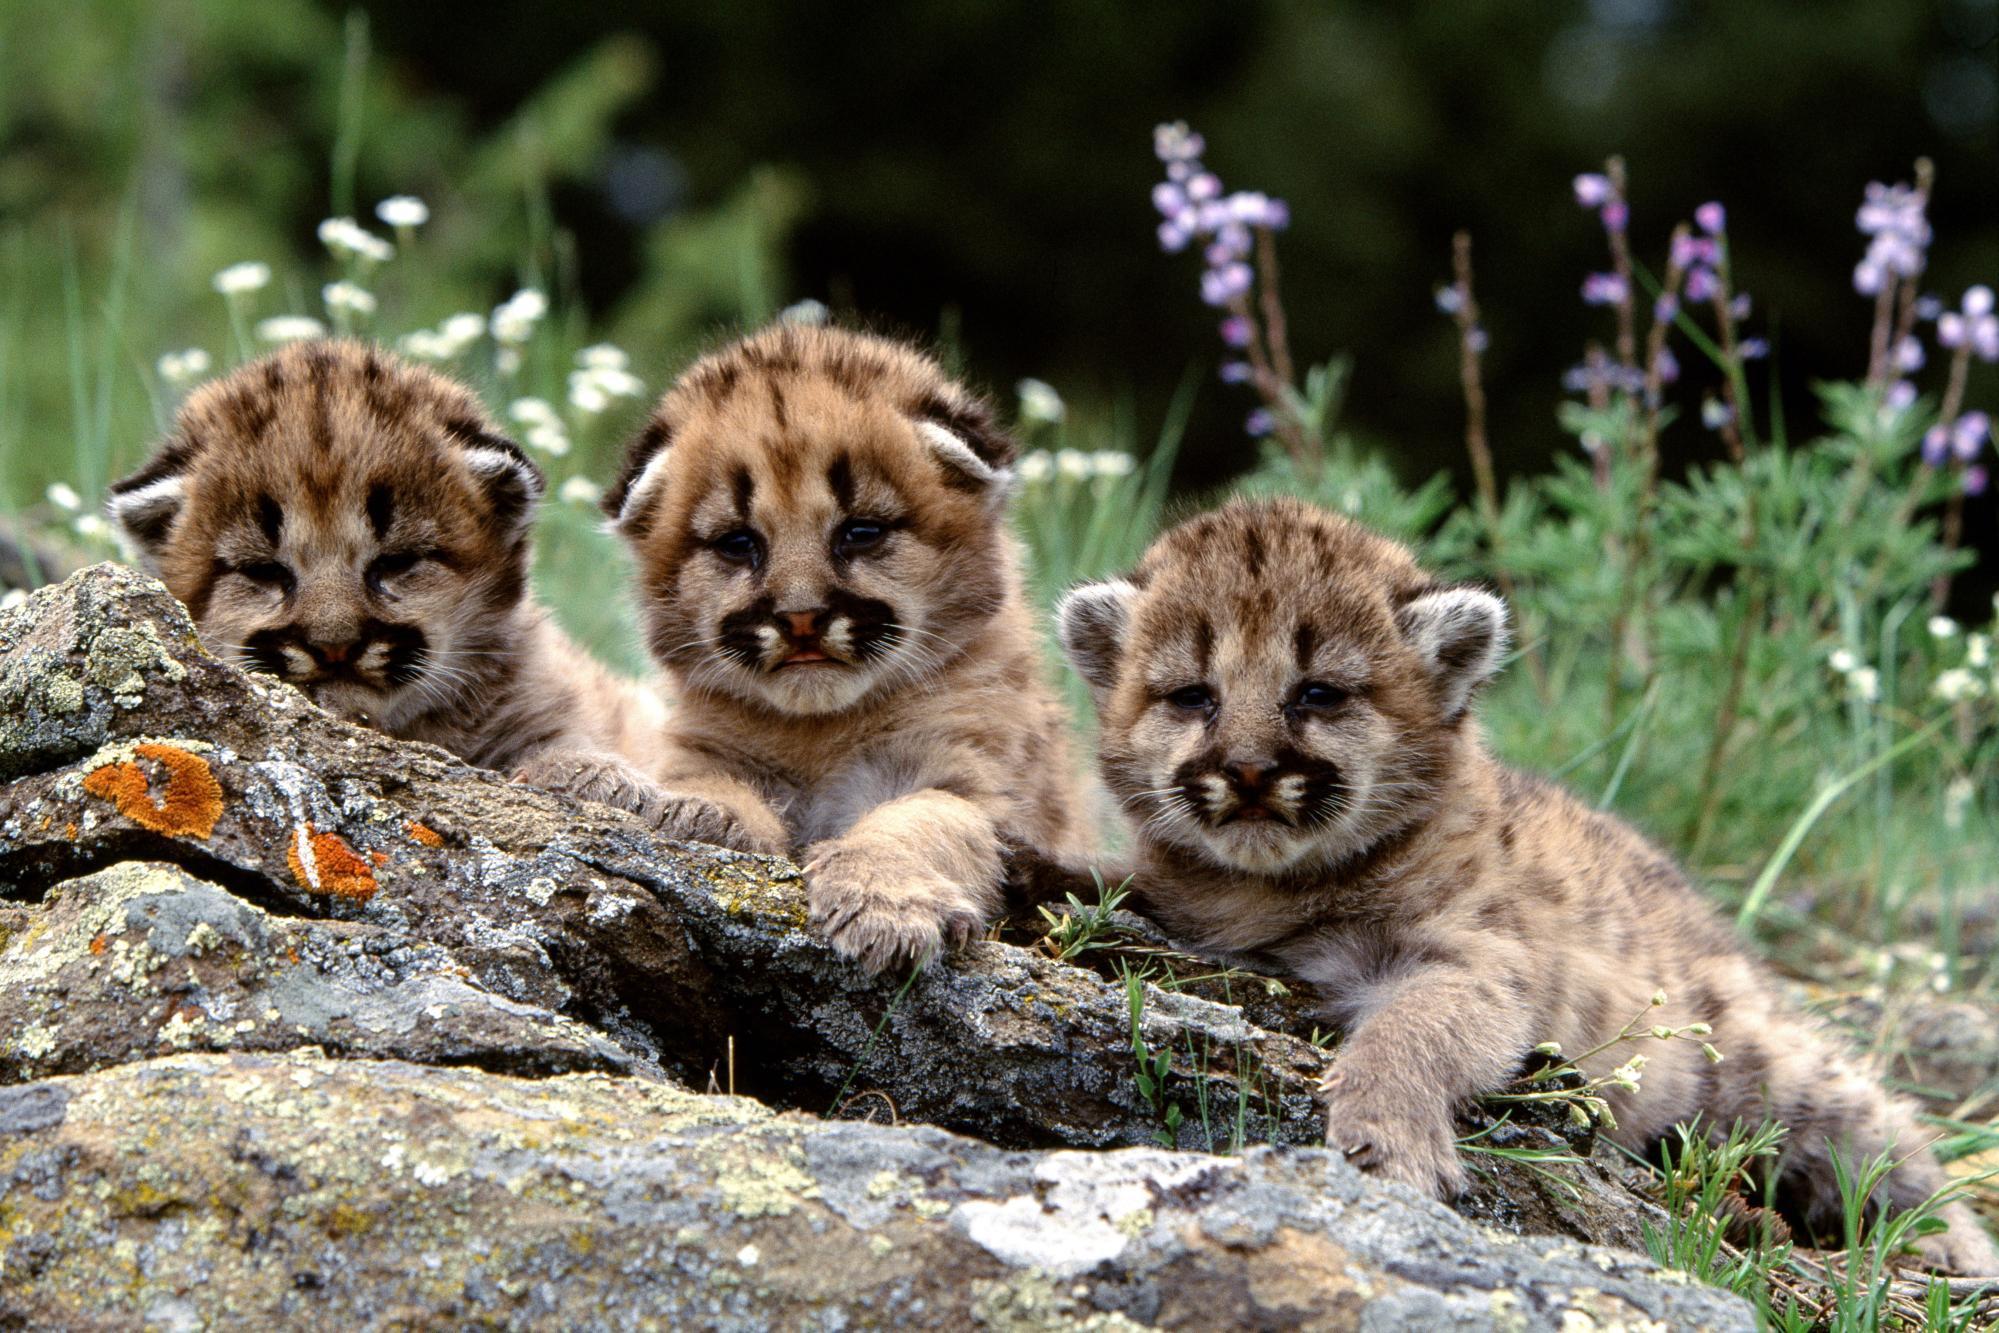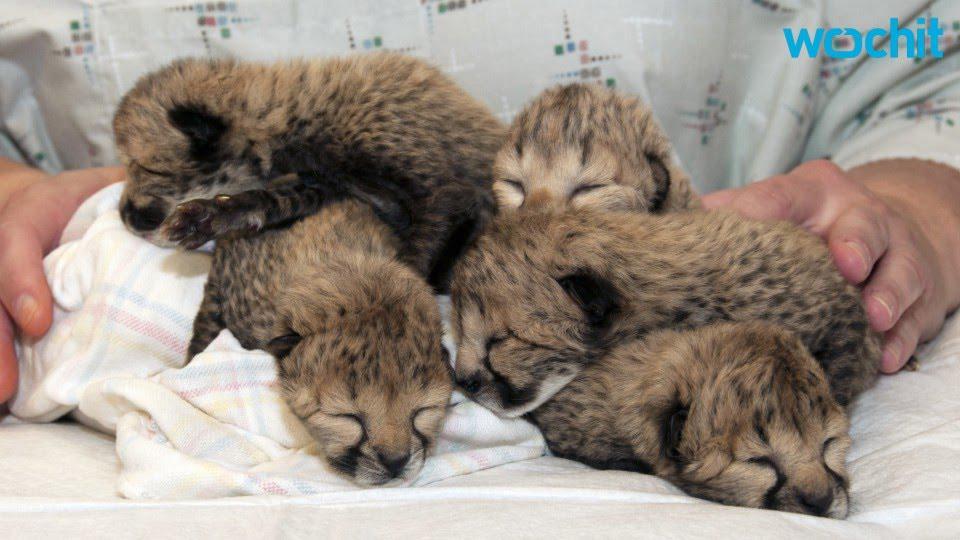The first image is the image on the left, the second image is the image on the right. Given the left and right images, does the statement "All of the animals shown are spotted wild kittens, and one image shows a group of wild kittens without fully open eyes in a pile on straw." hold true? Answer yes or no. No. The first image is the image on the left, the second image is the image on the right. Considering the images on both sides, is "In the image to the left, we see three kittens; the young of big cat breeds." valid? Answer yes or no. Yes. 